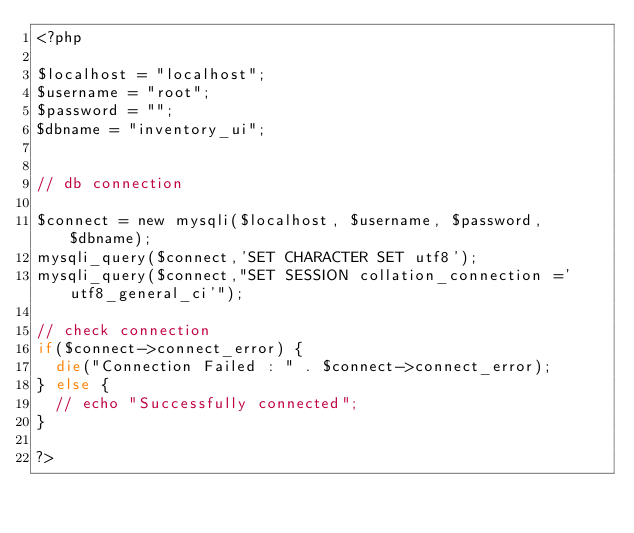<code> <loc_0><loc_0><loc_500><loc_500><_PHP_><?php 	

$localhost = "localhost";
$username = "root";
$password = "";
$dbname = "inventory_ui";


// db connection

$connect = new mysqli($localhost, $username, $password, $dbname);
mysqli_query($connect,'SET CHARACTER SET utf8');
mysqli_query($connect,"SET SESSION collation_connection ='utf8_general_ci'");

// check connection
if($connect->connect_error) {
  die("Connection Failed : " . $connect->connect_error);
} else {
  // echo "Successfully connected";
}

?></code> 